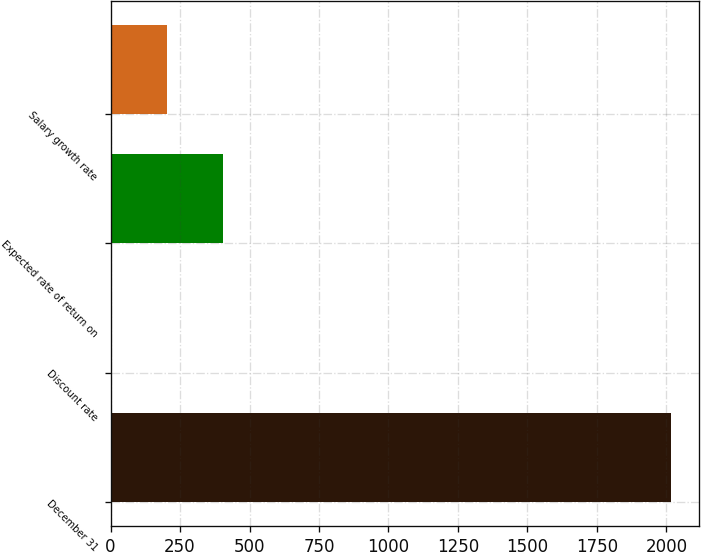<chart> <loc_0><loc_0><loc_500><loc_500><bar_chart><fcel>December 31<fcel>Discount rate<fcel>Expected rate of return on<fcel>Salary growth rate<nl><fcel>2017<fcel>2.2<fcel>405.16<fcel>203.68<nl></chart> 